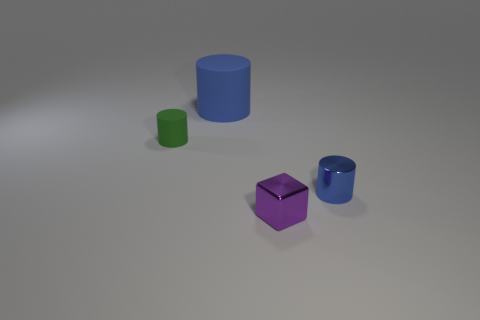Subtract all brown cubes. How many green cylinders are left? 1 Subtract all large gray shiny spheres. Subtract all matte things. How many objects are left? 2 Add 2 small green things. How many small green things are left? 3 Add 3 small blue metal cylinders. How many small blue metal cylinders exist? 4 Add 3 cyan objects. How many objects exist? 7 Subtract all blue cylinders. How many cylinders are left? 1 Subtract all blue cylinders. How many cylinders are left? 1 Subtract 0 brown cylinders. How many objects are left? 4 Subtract all cylinders. How many objects are left? 1 Subtract 1 cubes. How many cubes are left? 0 